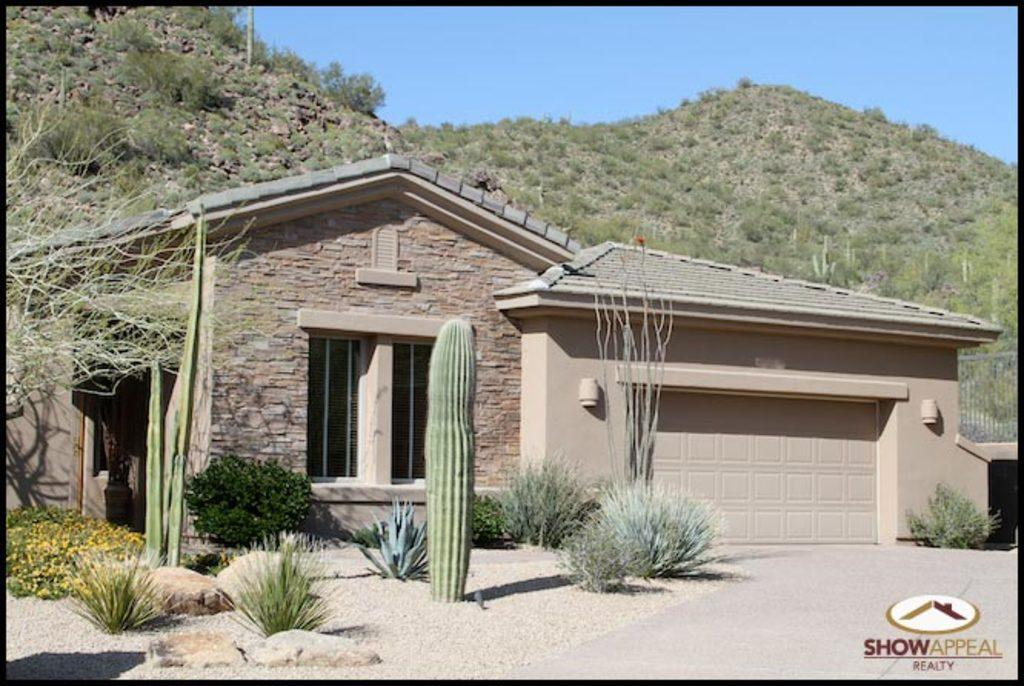What type of structure is visible in the image? There is a house in the image. What material is used for the wall of the house? The house has a stone wall. Are there any openings in the house? Yes, there is a door and a window in the house. What can be seen in the background of the image? There is a mountain and a clear sky in the background of the image. What type of humor is being displayed by the bushes in the image? There are no bushes present in the image, and therefore no humor can be attributed to them. 